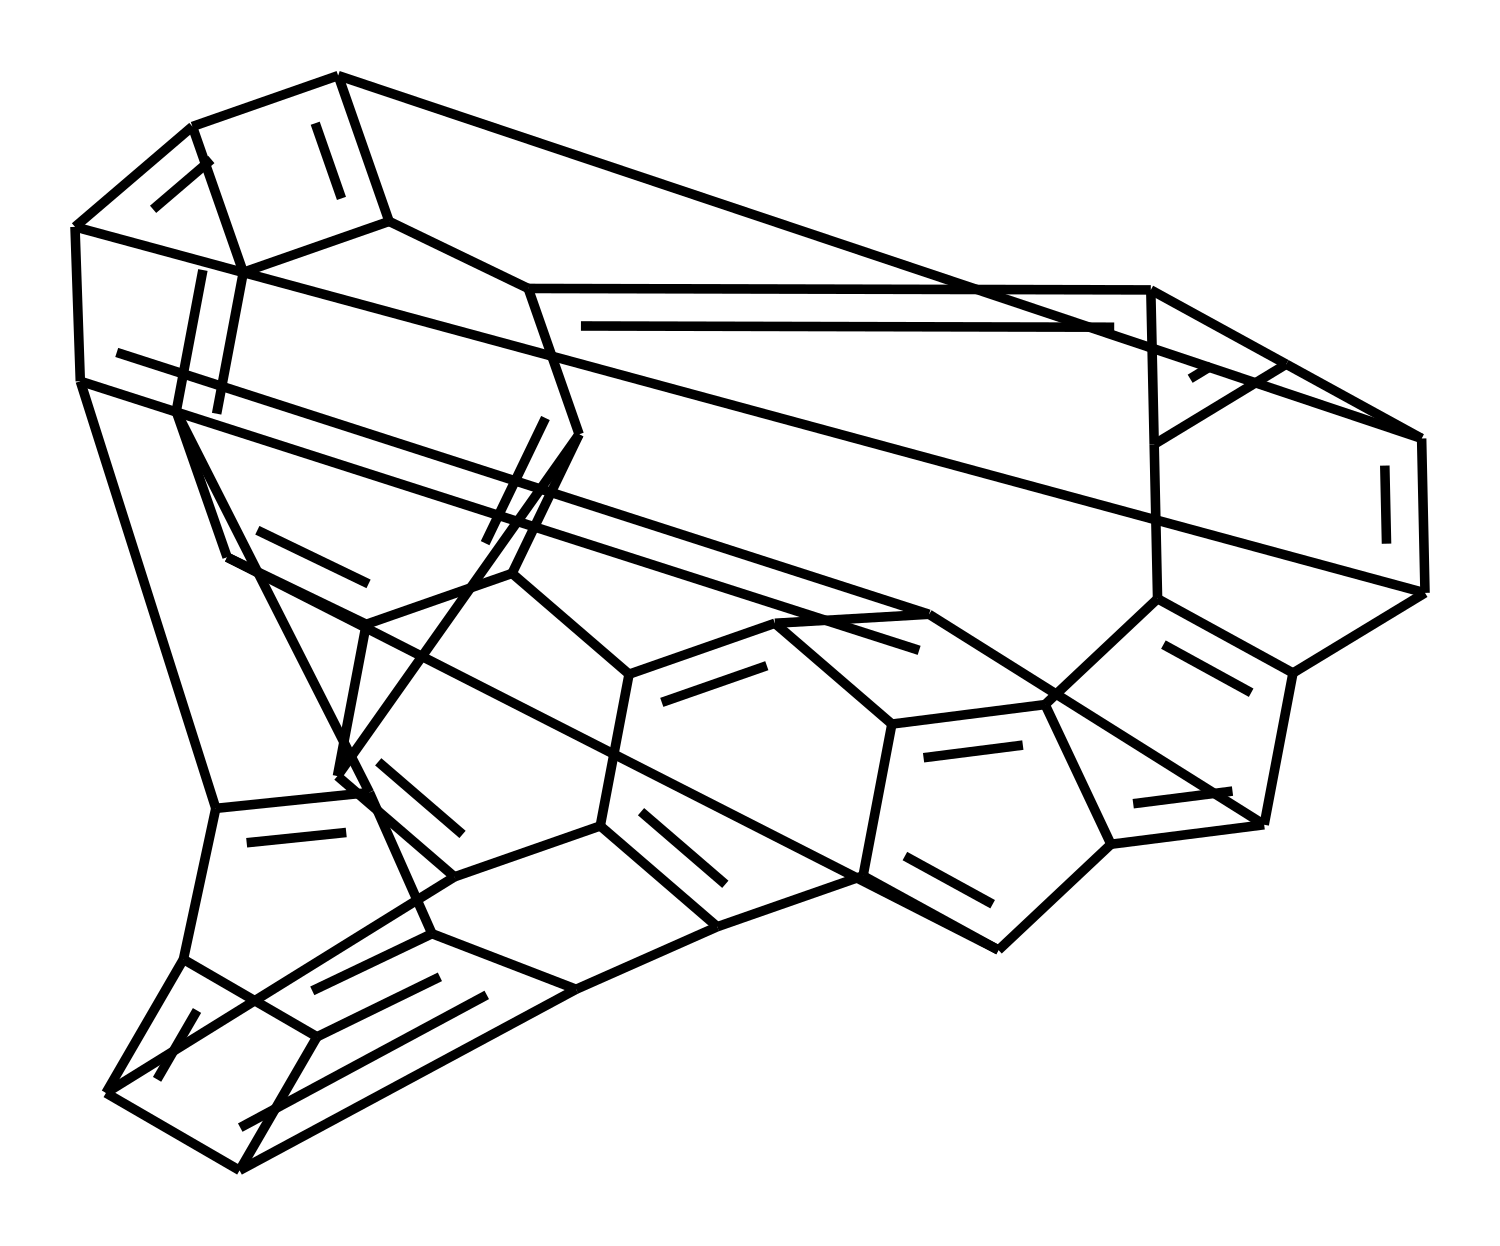What is the molecular formula of the compound represented by this SMILES? To determine the molecular formula, we need to count the number of each type of atom represented in the SMILES notation. From the structure, we can see that there are multiple carbon atoms and no other atoms are explicitly indicated, suggesting that it consists solely of carbon. The exact count of carbon atoms gives us the molecular formula.
Answer: C How many rings are present in the chemical structure? The representation includes cyclic structures; to find the number of rings, we can look for the numbers in the SMILES that indicate ring closures. Each time a digit appears, it signifies the start and end of a ring. By counting these closures, we can determine the total number of rings. In this case, they indicate the presence of multiple interconnected rings.
Answer: 10 What type of nanomaterial is indicated by this structure? The specific arrangement of carbon atoms in a tubular form, as suggested by the number of bonds and structures in the SMILES, implies that it denotes carbon nanotubes, a common type of nanomaterial known for their strength and lightweight properties.
Answer: carbon nanotubes What type of bonding is predominant in this chemical structure? Analysis of the SMILES shows that most connections between atoms are through covalent bonds, which are characteristic of the carbon structures here. The carbon atoms are linked strongly together, indicating robust covalent bonding throughout the structure.
Answer: covalent bonding What is the expected tensile strength of this nanomaterial? While the structure itself does not provide a numerical value, carbon nanotubes are generally known to exhibit extraordinarily high tensile strength, typically around 30 GPa. This knowledge is based on extensive research and characterization of carbon nanotubes.
Answer: 30 GPa What application can this structure serve in sculpture? Considering the properties of carbon nanotubes, such as lightness and strength, this structure can be used to create lightweight and durable sculptural materials. Artists and sculptors can leverage these properties for innovative designs.
Answer: lightweight and durable sculptures 